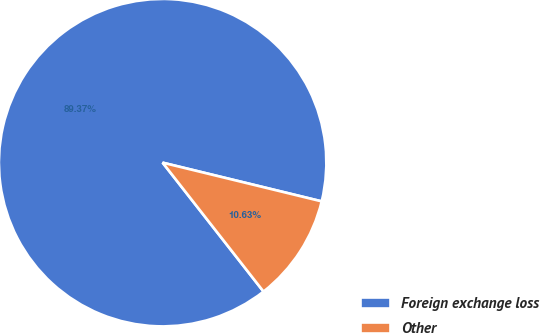<chart> <loc_0><loc_0><loc_500><loc_500><pie_chart><fcel>Foreign exchange loss<fcel>Other<nl><fcel>89.37%<fcel>10.63%<nl></chart> 